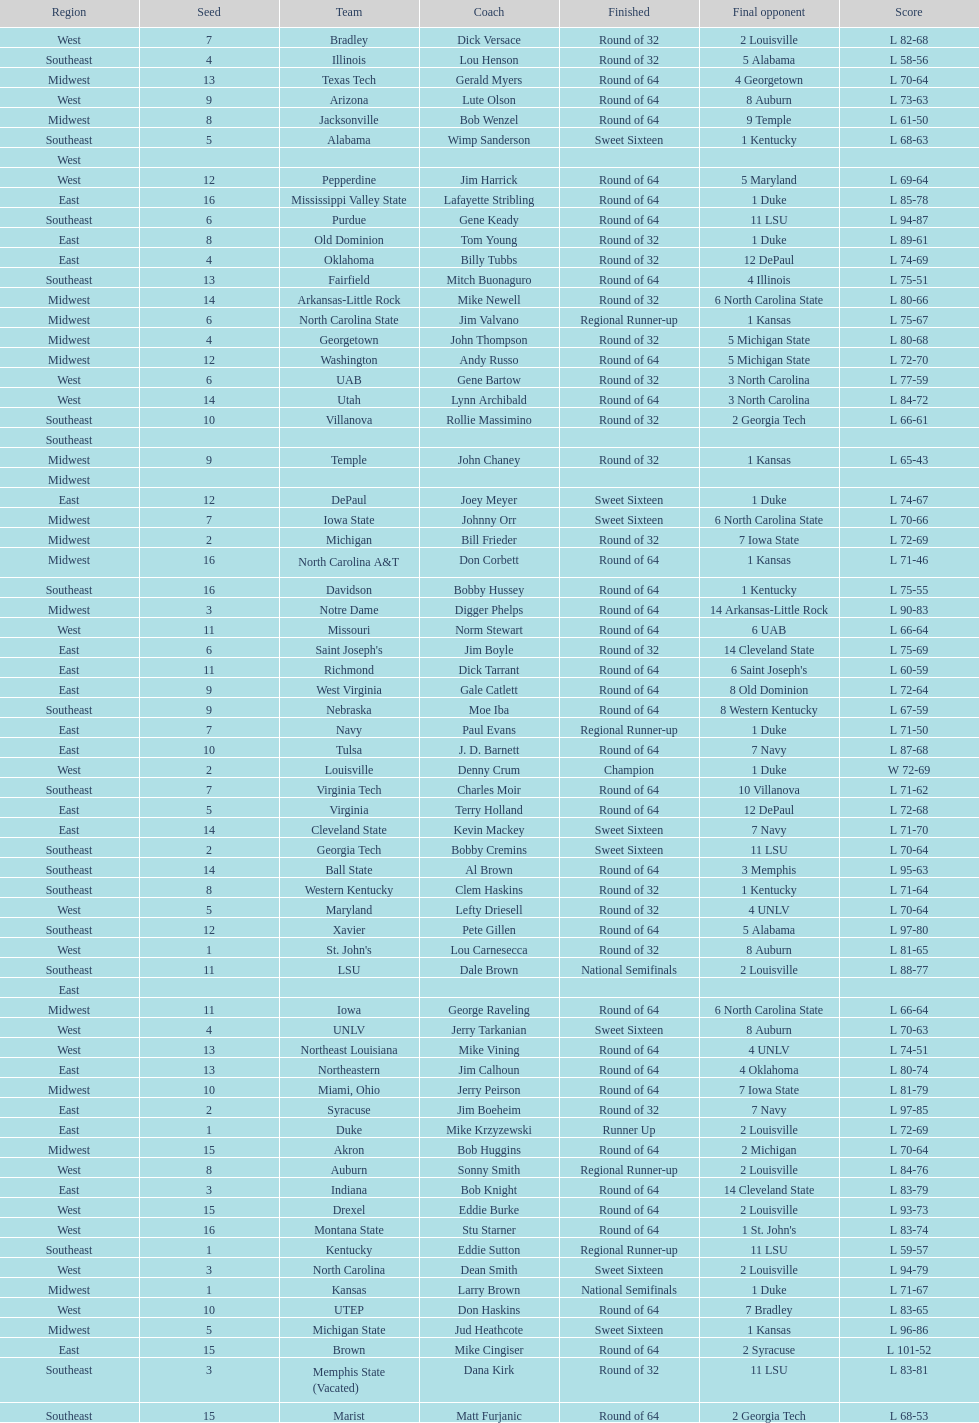How many number of teams played altogether? 64. Give me the full table as a dictionary. {'header': ['Region', 'Seed', 'Team', 'Coach', 'Finished', 'Final opponent', 'Score'], 'rows': [['West', '7', 'Bradley', 'Dick Versace', 'Round of 32', '2 Louisville', 'L 82-68'], ['Southeast', '4', 'Illinois', 'Lou Henson', 'Round of 32', '5 Alabama', 'L 58-56'], ['Midwest', '13', 'Texas Tech', 'Gerald Myers', 'Round of 64', '4 Georgetown', 'L 70-64'], ['West', '9', 'Arizona', 'Lute Olson', 'Round of 64', '8 Auburn', 'L 73-63'], ['Midwest', '8', 'Jacksonville', 'Bob Wenzel', 'Round of 64', '9 Temple', 'L 61-50'], ['Southeast', '5', 'Alabama', 'Wimp Sanderson', 'Sweet Sixteen', '1 Kentucky', 'L 68-63'], ['West', '', '', '', '', '', ''], ['West', '12', 'Pepperdine', 'Jim Harrick', 'Round of 64', '5 Maryland', 'L 69-64'], ['East', '16', 'Mississippi Valley State', 'Lafayette Stribling', 'Round of 64', '1 Duke', 'L 85-78'], ['Southeast', '6', 'Purdue', 'Gene Keady', 'Round of 64', '11 LSU', 'L 94-87'], ['East', '8', 'Old Dominion', 'Tom Young', 'Round of 32', '1 Duke', 'L 89-61'], ['East', '4', 'Oklahoma', 'Billy Tubbs', 'Round of 32', '12 DePaul', 'L 74-69'], ['Southeast', '13', 'Fairfield', 'Mitch Buonaguro', 'Round of 64', '4 Illinois', 'L 75-51'], ['Midwest', '14', 'Arkansas-Little Rock', 'Mike Newell', 'Round of 32', '6 North Carolina State', 'L 80-66'], ['Midwest', '6', 'North Carolina State', 'Jim Valvano', 'Regional Runner-up', '1 Kansas', 'L 75-67'], ['Midwest', '4', 'Georgetown', 'John Thompson', 'Round of 32', '5 Michigan State', 'L 80-68'], ['Midwest', '12', 'Washington', 'Andy Russo', 'Round of 64', '5 Michigan State', 'L 72-70'], ['West', '6', 'UAB', 'Gene Bartow', 'Round of 32', '3 North Carolina', 'L 77-59'], ['West', '14', 'Utah', 'Lynn Archibald', 'Round of 64', '3 North Carolina', 'L 84-72'], ['Southeast', '10', 'Villanova', 'Rollie Massimino', 'Round of 32', '2 Georgia Tech', 'L 66-61'], ['Southeast', '', '', '', '', '', ''], ['Midwest', '9', 'Temple', 'John Chaney', 'Round of 32', '1 Kansas', 'L 65-43'], ['Midwest', '', '', '', '', '', ''], ['East', '12', 'DePaul', 'Joey Meyer', 'Sweet Sixteen', '1 Duke', 'L 74-67'], ['Midwest', '7', 'Iowa State', 'Johnny Orr', 'Sweet Sixteen', '6 North Carolina State', 'L 70-66'], ['Midwest', '2', 'Michigan', 'Bill Frieder', 'Round of 32', '7 Iowa State', 'L 72-69'], ['Midwest', '16', 'North Carolina A&T', 'Don Corbett', 'Round of 64', '1 Kansas', 'L 71-46'], ['Southeast', '16', 'Davidson', 'Bobby Hussey', 'Round of 64', '1 Kentucky', 'L 75-55'], ['Midwest', '3', 'Notre Dame', 'Digger Phelps', 'Round of 64', '14 Arkansas-Little Rock', 'L 90-83'], ['West', '11', 'Missouri', 'Norm Stewart', 'Round of 64', '6 UAB', 'L 66-64'], ['East', '6', "Saint Joseph's", 'Jim Boyle', 'Round of 32', '14 Cleveland State', 'L 75-69'], ['East', '11', 'Richmond', 'Dick Tarrant', 'Round of 64', "6 Saint Joseph's", 'L 60-59'], ['East', '9', 'West Virginia', 'Gale Catlett', 'Round of 64', '8 Old Dominion', 'L 72-64'], ['Southeast', '9', 'Nebraska', 'Moe Iba', 'Round of 64', '8 Western Kentucky', 'L 67-59'], ['East', '7', 'Navy', 'Paul Evans', 'Regional Runner-up', '1 Duke', 'L 71-50'], ['East', '10', 'Tulsa', 'J. D. Barnett', 'Round of 64', '7 Navy', 'L 87-68'], ['West', '2', 'Louisville', 'Denny Crum', 'Champion', '1 Duke', 'W 72-69'], ['Southeast', '7', 'Virginia Tech', 'Charles Moir', 'Round of 64', '10 Villanova', 'L 71-62'], ['East', '5', 'Virginia', 'Terry Holland', 'Round of 64', '12 DePaul', 'L 72-68'], ['East', '14', 'Cleveland State', 'Kevin Mackey', 'Sweet Sixteen', '7 Navy', 'L 71-70'], ['Southeast', '2', 'Georgia Tech', 'Bobby Cremins', 'Sweet Sixteen', '11 LSU', 'L 70-64'], ['Southeast', '14', 'Ball State', 'Al Brown', 'Round of 64', '3 Memphis', 'L 95-63'], ['Southeast', '8', 'Western Kentucky', 'Clem Haskins', 'Round of 32', '1 Kentucky', 'L 71-64'], ['West', '5', 'Maryland', 'Lefty Driesell', 'Round of 32', '4 UNLV', 'L 70-64'], ['Southeast', '12', 'Xavier', 'Pete Gillen', 'Round of 64', '5 Alabama', 'L 97-80'], ['West', '1', "St. John's", 'Lou Carnesecca', 'Round of 32', '8 Auburn', 'L 81-65'], ['Southeast', '11', 'LSU', 'Dale Brown', 'National Semifinals', '2 Louisville', 'L 88-77'], ['East', '', '', '', '', '', ''], ['Midwest', '11', 'Iowa', 'George Raveling', 'Round of 64', '6 North Carolina State', 'L 66-64'], ['West', '4', 'UNLV', 'Jerry Tarkanian', 'Sweet Sixteen', '8 Auburn', 'L 70-63'], ['West', '13', 'Northeast Louisiana', 'Mike Vining', 'Round of 64', '4 UNLV', 'L 74-51'], ['East', '13', 'Northeastern', 'Jim Calhoun', 'Round of 64', '4 Oklahoma', 'L 80-74'], ['Midwest', '10', 'Miami, Ohio', 'Jerry Peirson', 'Round of 64', '7 Iowa State', 'L 81-79'], ['East', '2', 'Syracuse', 'Jim Boeheim', 'Round of 32', '7 Navy', 'L 97-85'], ['East', '1', 'Duke', 'Mike Krzyzewski', 'Runner Up', '2 Louisville', 'L 72-69'], ['Midwest', '15', 'Akron', 'Bob Huggins', 'Round of 64', '2 Michigan', 'L 70-64'], ['West', '8', 'Auburn', 'Sonny Smith', 'Regional Runner-up', '2 Louisville', 'L 84-76'], ['East', '3', 'Indiana', 'Bob Knight', 'Round of 64', '14 Cleveland State', 'L 83-79'], ['West', '15', 'Drexel', 'Eddie Burke', 'Round of 64', '2 Louisville', 'L 93-73'], ['West', '16', 'Montana State', 'Stu Starner', 'Round of 64', "1 St. John's", 'L 83-74'], ['Southeast', '1', 'Kentucky', 'Eddie Sutton', 'Regional Runner-up', '11 LSU', 'L 59-57'], ['West', '3', 'North Carolina', 'Dean Smith', 'Sweet Sixteen', '2 Louisville', 'L 94-79'], ['Midwest', '1', 'Kansas', 'Larry Brown', 'National Semifinals', '1 Duke', 'L 71-67'], ['West', '10', 'UTEP', 'Don Haskins', 'Round of 64', '7 Bradley', 'L 83-65'], ['Midwest', '5', 'Michigan State', 'Jud Heathcote', 'Sweet Sixteen', '1 Kansas', 'L 96-86'], ['East', '15', 'Brown', 'Mike Cingiser', 'Round of 64', '2 Syracuse', 'L 101-52'], ['Southeast', '3', 'Memphis State (Vacated)', 'Dana Kirk', 'Round of 32', '11 LSU', 'L 83-81'], ['Southeast', '15', 'Marist', 'Matt Furjanic', 'Round of 64', '2 Georgia Tech', 'L 68-53']]} 